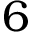Convert formula to latex. <formula><loc_0><loc_0><loc_500><loc_500>6</formula> 